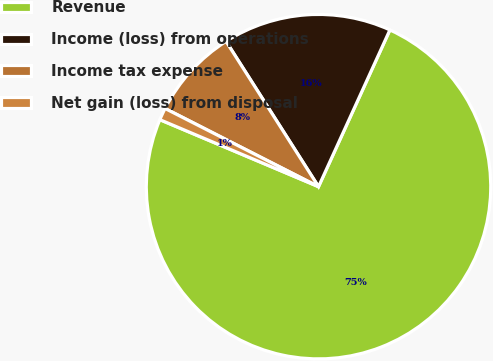Convert chart to OTSL. <chart><loc_0><loc_0><loc_500><loc_500><pie_chart><fcel>Revenue<fcel>Income (loss) from operations<fcel>Income tax expense<fcel>Net gain (loss) from disposal<nl><fcel>74.55%<fcel>15.82%<fcel>8.48%<fcel>1.14%<nl></chart> 